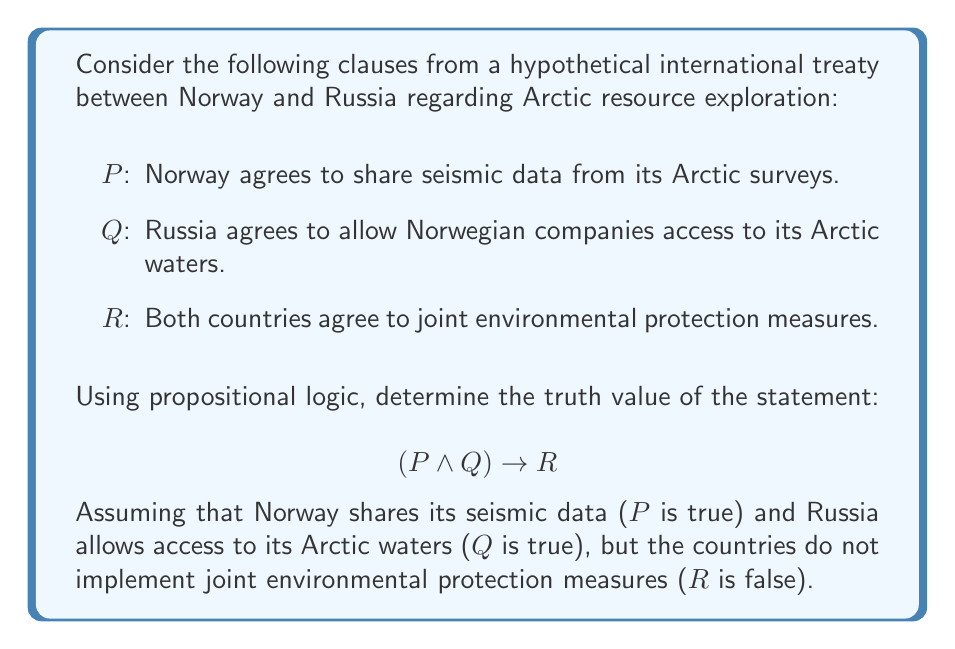Can you solve this math problem? Let's approach this step-by-step using propositional logic:

1) We are given that:
   P is true (T)
   Q is true (T)
   R is false (F)

2) The statement we need to evaluate is $(P \wedge Q) \rightarrow R$

3) Let's start by evaluating the left side of the implication: $(P \wedge Q)$
   $P \wedge Q = T \wedge T = T$

4) Now our statement looks like: $T \rightarrow F$

5) Recall the truth table for implication ($\rightarrow$):
   $$\begin{array}{c|c|c}
   p & q & p \rightarrow q \\
   \hline
   T & T & T \\
   T & F & F \\
   F & T & T \\
   F & F & T
   \end{array}$$

6) From this table, we can see that when the antecedent (left side) is true and the consequent (right side) is false, the implication is false.

7) Therefore, $(P \wedge Q) \rightarrow R$ evaluates to false.

This result suggests that if both Norway and Russia fulfill their individual commitments (sharing data and allowing access) but fail to implement joint environmental protection measures, they would be in violation of this clause of the treaty.
Answer: False 